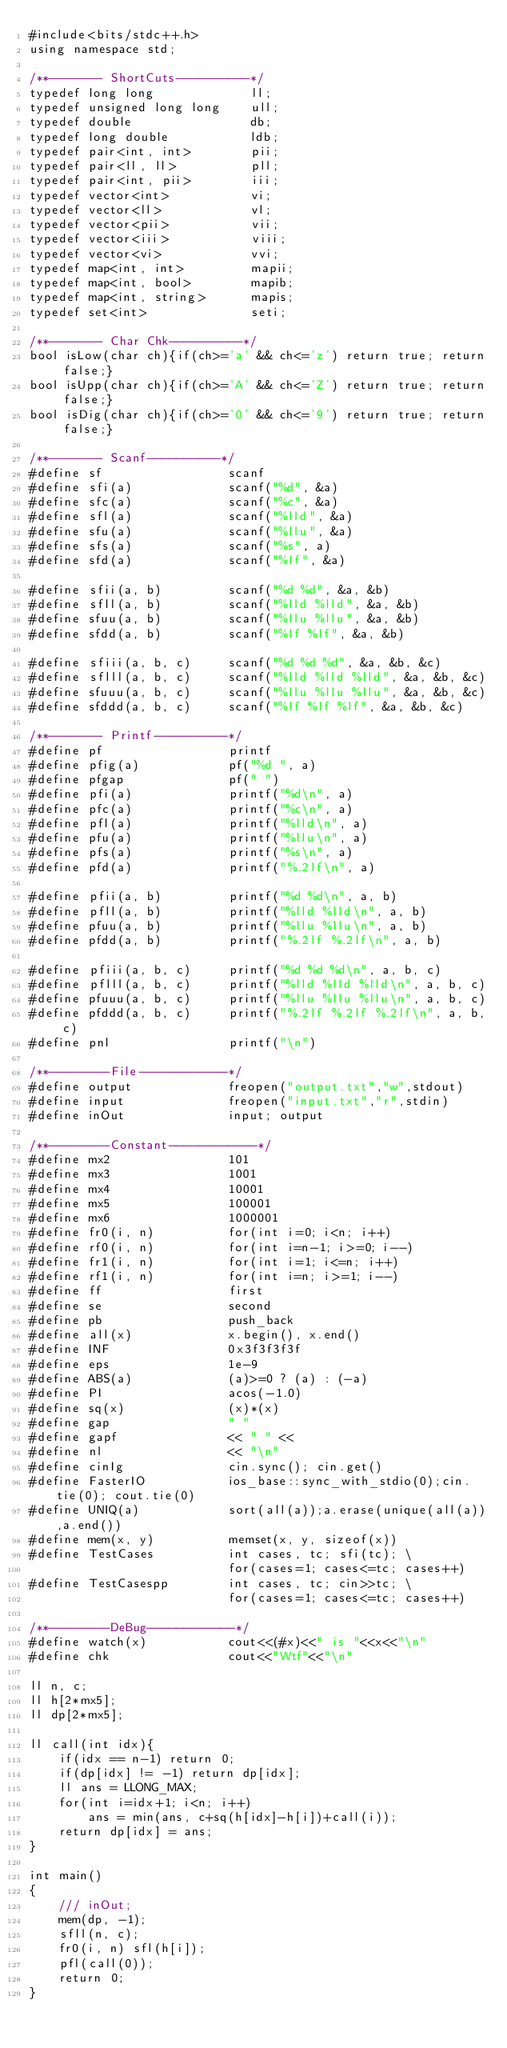<code> <loc_0><loc_0><loc_500><loc_500><_C++_>#include<bits/stdc++.h>
using namespace std;

/**------- ShortCuts----------*/
typedef long long             ll;
typedef unsigned long long    ull;
typedef double                db;
typedef long double           ldb;
typedef pair<int, int>        pii;
typedef pair<ll, ll>          pll;
typedef pair<int, pii>        iii;
typedef vector<int>           vi;
typedef vector<ll>            vl;
typedef vector<pii>           vii;
typedef vector<iii>           viii;
typedef vector<vi>            vvi;
typedef map<int, int>         mapii;
typedef map<int, bool>        mapib;
typedef map<int, string>      mapis;
typedef set<int>              seti;

/**------- Char Chk----------*/
bool isLow(char ch){if(ch>='a' && ch<='z') return true; return false;}
bool isUpp(char ch){if(ch>='A' && ch<='Z') return true; return false;}
bool isDig(char ch){if(ch>='0' && ch<='9') return true; return false;}

/**------- Scanf----------*/
#define sf                 scanf
#define sfi(a)             scanf("%d", &a)
#define sfc(a)             scanf("%c", &a)
#define sfl(a)             scanf("%lld", &a)
#define sfu(a)             scanf("%llu", &a)
#define sfs(a)             scanf("%s", a)
#define sfd(a)             scanf("%lf", &a)

#define sfii(a, b)         scanf("%d %d", &a, &b)
#define sfll(a, b)         scanf("%lld %lld", &a, &b)
#define sfuu(a, b)         scanf("%llu %llu", &a, &b)
#define sfdd(a, b)         scanf("%lf %lf", &a, &b)

#define sfiii(a, b, c)     scanf("%d %d %d", &a, &b, &c)
#define sflll(a, b, c)     scanf("%lld %lld %lld", &a, &b, &c)
#define sfuuu(a, b, c)     scanf("%llu %llu %llu", &a, &b, &c)
#define sfddd(a, b, c)     scanf("%lf %lf %lf", &a, &b, &c)

/**------- Printf----------*/
#define pf                 printf
#define pfig(a)            pf("%d ", a)
#define pfgap              pf(" ")
#define pfi(a)             printf("%d\n", a)
#define pfc(a)             printf("%c\n", a)
#define pfl(a)             printf("%lld\n", a)
#define pfu(a)             printf("%llu\n", a)
#define pfs(a)             printf("%s\n", a)
#define pfd(a)             printf("%.2lf\n", a)

#define pfii(a, b)         printf("%d %d\n", a, b)
#define pfll(a, b)         printf("%lld %lld\n", a, b)
#define pfuu(a, b)         printf("%llu %llu\n", a, b)
#define pfdd(a, b)         printf("%.2lf %.2lf\n", a, b)

#define pfiii(a, b, c)     printf("%d %d %d\n", a, b, c)
#define pflll(a, b, c)     printf("%lld %lld %lld\n", a, b, c)
#define pfuuu(a, b, c)     printf("%llu %llu %llu\n", a, b, c)
#define pfddd(a, b, c)     printf("%.2lf %.2lf %.2lf\n", a, b, c)
#define pnl                printf("\n")

/**--------File------------*/
#define output             freopen("output.txt","w",stdout)
#define input              freopen("input.txt","r",stdin)
#define inOut              input; output

/**--------Constant------------*/
#define mx2                101
#define mx3                1001
#define mx4                10001
#define mx5                100001
#define mx6                1000001
#define fr0(i, n)          for(int i=0; i<n; i++)
#define rf0(i, n)          for(int i=n-1; i>=0; i--)
#define fr1(i, n)          for(int i=1; i<=n; i++)
#define rf1(i, n)          for(int i=n; i>=1; i--)
#define ff                 first
#define se                 second
#define pb                 push_back
#define all(x)             x.begin(), x.end()
#define INF                0x3f3f3f3f
#define eps                1e-9
#define ABS(a)             (a)>=0 ? (a) : (-a)
#define PI                 acos(-1.0)
#define sq(x)              (x)*(x)
#define gap                " "
#define gapf               << " " <<
#define nl                 << "\n"
#define cinIg              cin.sync(); cin.get()
#define FasterIO           ios_base::sync_with_stdio(0);cin.tie(0); cout.tie(0)
#define UNIQ(a)            sort(all(a));a.erase(unique(all(a)),a.end())
#define mem(x, y)          memset(x, y, sizeof(x))
#define TestCases          int cases, tc; sfi(tc); \
                           for(cases=1; cases<=tc; cases++)
#define TestCasespp        int cases, tc; cin>>tc; \
                           for(cases=1; cases<=tc; cases++)

/**--------DeBug------------*/
#define watch(x)           cout<<(#x)<<" is "<<x<<"\n"
#define chk                cout<<"Wtf"<<"\n"

ll n, c;
ll h[2*mx5];
ll dp[2*mx5];

ll call(int idx){
    if(idx == n-1) return 0;
    if(dp[idx] != -1) return dp[idx];
    ll ans = LLONG_MAX;
    for(int i=idx+1; i<n; i++)
        ans = min(ans, c+sq(h[idx]-h[i])+call(i));
    return dp[idx] = ans;
}

int main()
{
    /// inOut;
    mem(dp, -1);
    sfll(n, c);
    fr0(i, n) sfl(h[i]);
    pfl(call(0));
    return 0;
}

</code> 